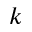<formula> <loc_0><loc_0><loc_500><loc_500>k</formula> 